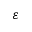<formula> <loc_0><loc_0><loc_500><loc_500>\varepsilon</formula> 